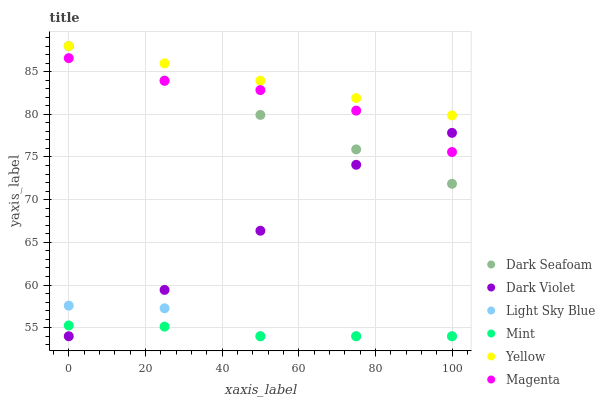Does Mint have the minimum area under the curve?
Answer yes or no. Yes. Does Yellow have the maximum area under the curve?
Answer yes or no. Yes. Does Dark Seafoam have the minimum area under the curve?
Answer yes or no. No. Does Dark Seafoam have the maximum area under the curve?
Answer yes or no. No. Is Yellow the smoothest?
Answer yes or no. Yes. Is Dark Violet the roughest?
Answer yes or no. Yes. Is Dark Seafoam the smoothest?
Answer yes or no. No. Is Dark Seafoam the roughest?
Answer yes or no. No. Does Light Sky Blue have the lowest value?
Answer yes or no. Yes. Does Dark Seafoam have the lowest value?
Answer yes or no. No. Does Dark Seafoam have the highest value?
Answer yes or no. Yes. Does Light Sky Blue have the highest value?
Answer yes or no. No. Is Light Sky Blue less than Magenta?
Answer yes or no. Yes. Is Magenta greater than Light Sky Blue?
Answer yes or no. Yes. Does Dark Violet intersect Mint?
Answer yes or no. Yes. Is Dark Violet less than Mint?
Answer yes or no. No. Is Dark Violet greater than Mint?
Answer yes or no. No. Does Light Sky Blue intersect Magenta?
Answer yes or no. No. 